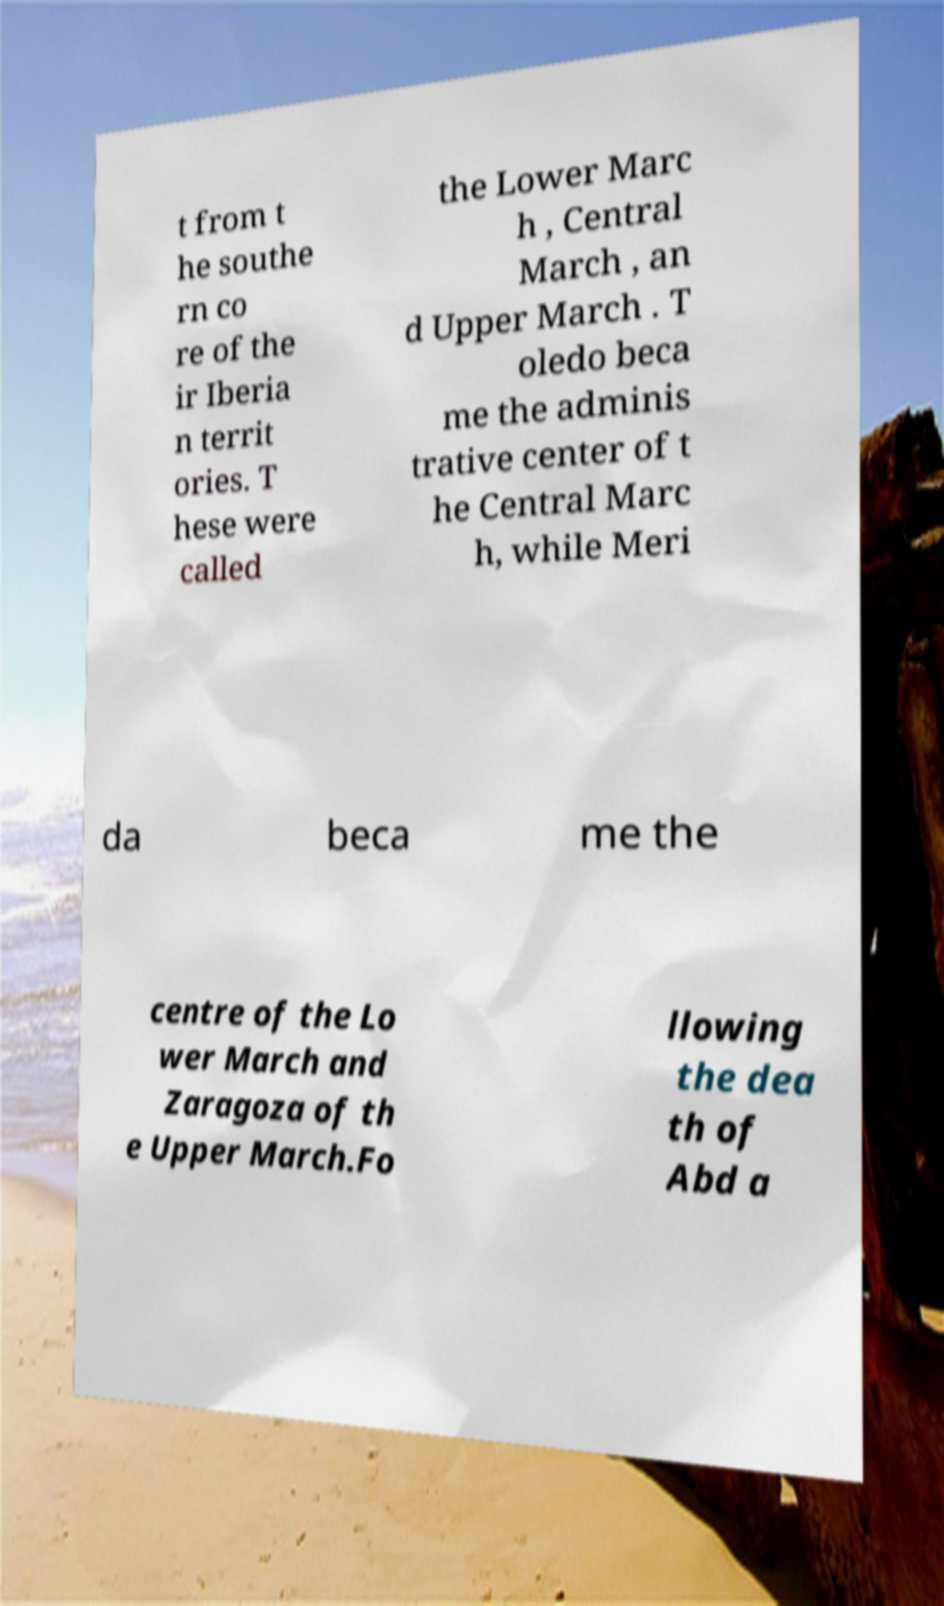Please read and relay the text visible in this image. What does it say? t from t he southe rn co re of the ir Iberia n territ ories. T hese were called the Lower Marc h , Central March , an d Upper March . T oledo beca me the adminis trative center of t he Central Marc h, while Meri da beca me the centre of the Lo wer March and Zaragoza of th e Upper March.Fo llowing the dea th of Abd a 